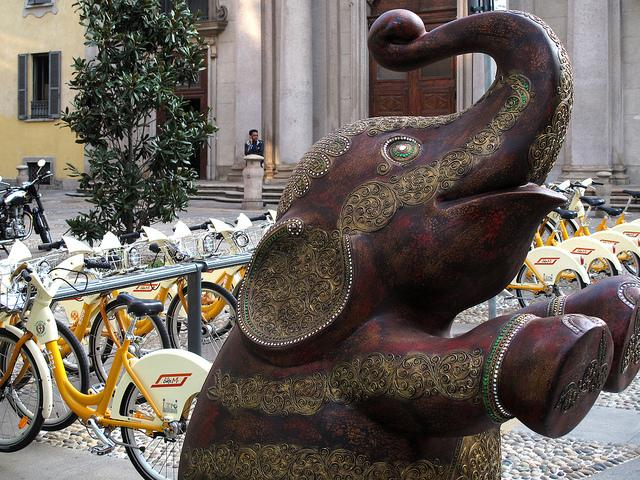Why are all the bikes the same?

Choices:
A) family owned
B) rentals
C) trends
D) government issued rentals 